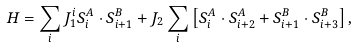Convert formula to latex. <formula><loc_0><loc_0><loc_500><loc_500>H = \sum _ { i } J _ { 1 } ^ { i } S _ { i } ^ { A } \cdot S _ { i + 1 } ^ { B } + J _ { 2 } \sum _ { i } \left [ S _ { i } ^ { A } \cdot S _ { i + 2 } ^ { A } + S _ { i + 1 } ^ { B } \cdot S _ { i + 3 } ^ { B } \right ] ,</formula> 